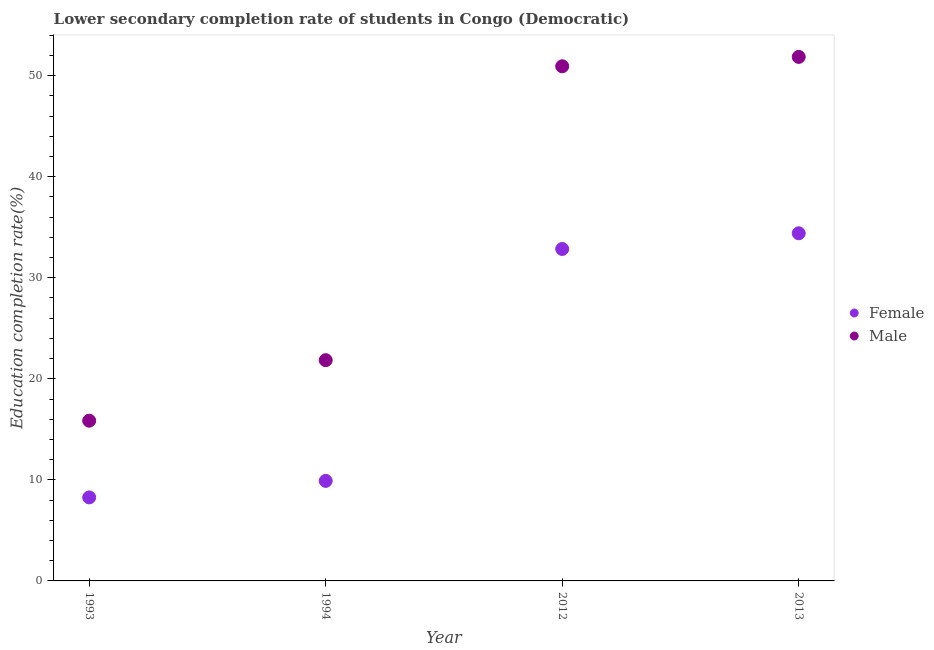Is the number of dotlines equal to the number of legend labels?
Your response must be concise. Yes. What is the education completion rate of female students in 1993?
Your answer should be very brief. 8.26. Across all years, what is the maximum education completion rate of male students?
Provide a succinct answer. 51.86. Across all years, what is the minimum education completion rate of male students?
Offer a terse response. 15.86. In which year was the education completion rate of female students maximum?
Your answer should be compact. 2013. In which year was the education completion rate of female students minimum?
Offer a very short reply. 1993. What is the total education completion rate of female students in the graph?
Make the answer very short. 85.41. What is the difference between the education completion rate of male students in 1994 and that in 2012?
Your response must be concise. -29.08. What is the difference between the education completion rate of male students in 1994 and the education completion rate of female students in 2012?
Offer a terse response. -11. What is the average education completion rate of female students per year?
Ensure brevity in your answer.  21.35. In the year 1993, what is the difference between the education completion rate of female students and education completion rate of male students?
Offer a very short reply. -7.59. In how many years, is the education completion rate of male students greater than 38 %?
Your response must be concise. 2. What is the ratio of the education completion rate of female students in 1994 to that in 2012?
Offer a very short reply. 0.3. Is the difference between the education completion rate of male students in 2012 and 2013 greater than the difference between the education completion rate of female students in 2012 and 2013?
Ensure brevity in your answer.  Yes. What is the difference between the highest and the second highest education completion rate of male students?
Keep it short and to the point. 0.93. What is the difference between the highest and the lowest education completion rate of female students?
Your answer should be compact. 26.14. In how many years, is the education completion rate of male students greater than the average education completion rate of male students taken over all years?
Your response must be concise. 2. How many dotlines are there?
Give a very brief answer. 2. Does the graph contain grids?
Keep it short and to the point. No. Where does the legend appear in the graph?
Offer a very short reply. Center right. How many legend labels are there?
Ensure brevity in your answer.  2. What is the title of the graph?
Your answer should be compact. Lower secondary completion rate of students in Congo (Democratic). Does "Private creditors" appear as one of the legend labels in the graph?
Provide a succinct answer. No. What is the label or title of the X-axis?
Ensure brevity in your answer.  Year. What is the label or title of the Y-axis?
Your response must be concise. Education completion rate(%). What is the Education completion rate(%) of Female in 1993?
Your answer should be very brief. 8.26. What is the Education completion rate(%) in Male in 1993?
Your answer should be compact. 15.86. What is the Education completion rate(%) of Female in 1994?
Offer a terse response. 9.9. What is the Education completion rate(%) of Male in 1994?
Offer a very short reply. 21.85. What is the Education completion rate(%) in Female in 2012?
Offer a very short reply. 32.85. What is the Education completion rate(%) in Male in 2012?
Give a very brief answer. 50.93. What is the Education completion rate(%) of Female in 2013?
Ensure brevity in your answer.  34.4. What is the Education completion rate(%) in Male in 2013?
Make the answer very short. 51.86. Across all years, what is the maximum Education completion rate(%) in Female?
Offer a terse response. 34.4. Across all years, what is the maximum Education completion rate(%) of Male?
Your response must be concise. 51.86. Across all years, what is the minimum Education completion rate(%) in Female?
Offer a very short reply. 8.26. Across all years, what is the minimum Education completion rate(%) in Male?
Give a very brief answer. 15.86. What is the total Education completion rate(%) of Female in the graph?
Offer a terse response. 85.41. What is the total Education completion rate(%) in Male in the graph?
Ensure brevity in your answer.  140.49. What is the difference between the Education completion rate(%) in Female in 1993 and that in 1994?
Ensure brevity in your answer.  -1.64. What is the difference between the Education completion rate(%) in Male in 1993 and that in 1994?
Ensure brevity in your answer.  -5.99. What is the difference between the Education completion rate(%) in Female in 1993 and that in 2012?
Your answer should be very brief. -24.59. What is the difference between the Education completion rate(%) of Male in 1993 and that in 2012?
Offer a very short reply. -35.07. What is the difference between the Education completion rate(%) of Female in 1993 and that in 2013?
Your response must be concise. -26.14. What is the difference between the Education completion rate(%) in Male in 1993 and that in 2013?
Keep it short and to the point. -36. What is the difference between the Education completion rate(%) of Female in 1994 and that in 2012?
Offer a terse response. -22.95. What is the difference between the Education completion rate(%) in Male in 1994 and that in 2012?
Your answer should be compact. -29.08. What is the difference between the Education completion rate(%) in Female in 1994 and that in 2013?
Ensure brevity in your answer.  -24.5. What is the difference between the Education completion rate(%) in Male in 1994 and that in 2013?
Provide a succinct answer. -30.01. What is the difference between the Education completion rate(%) of Female in 2012 and that in 2013?
Your response must be concise. -1.55. What is the difference between the Education completion rate(%) of Male in 2012 and that in 2013?
Make the answer very short. -0.93. What is the difference between the Education completion rate(%) in Female in 1993 and the Education completion rate(%) in Male in 1994?
Your answer should be compact. -13.58. What is the difference between the Education completion rate(%) of Female in 1993 and the Education completion rate(%) of Male in 2012?
Your response must be concise. -42.66. What is the difference between the Education completion rate(%) in Female in 1993 and the Education completion rate(%) in Male in 2013?
Your response must be concise. -43.59. What is the difference between the Education completion rate(%) of Female in 1994 and the Education completion rate(%) of Male in 2012?
Your answer should be compact. -41.03. What is the difference between the Education completion rate(%) of Female in 1994 and the Education completion rate(%) of Male in 2013?
Ensure brevity in your answer.  -41.96. What is the difference between the Education completion rate(%) of Female in 2012 and the Education completion rate(%) of Male in 2013?
Offer a terse response. -19.01. What is the average Education completion rate(%) in Female per year?
Your answer should be compact. 21.35. What is the average Education completion rate(%) of Male per year?
Make the answer very short. 35.12. In the year 1993, what is the difference between the Education completion rate(%) of Female and Education completion rate(%) of Male?
Provide a short and direct response. -7.59. In the year 1994, what is the difference between the Education completion rate(%) of Female and Education completion rate(%) of Male?
Make the answer very short. -11.95. In the year 2012, what is the difference between the Education completion rate(%) in Female and Education completion rate(%) in Male?
Provide a short and direct response. -18.08. In the year 2013, what is the difference between the Education completion rate(%) in Female and Education completion rate(%) in Male?
Your answer should be compact. -17.45. What is the ratio of the Education completion rate(%) in Female in 1993 to that in 1994?
Provide a succinct answer. 0.83. What is the ratio of the Education completion rate(%) in Male in 1993 to that in 1994?
Offer a very short reply. 0.73. What is the ratio of the Education completion rate(%) of Female in 1993 to that in 2012?
Give a very brief answer. 0.25. What is the ratio of the Education completion rate(%) in Male in 1993 to that in 2012?
Make the answer very short. 0.31. What is the ratio of the Education completion rate(%) in Female in 1993 to that in 2013?
Your answer should be compact. 0.24. What is the ratio of the Education completion rate(%) of Male in 1993 to that in 2013?
Ensure brevity in your answer.  0.31. What is the ratio of the Education completion rate(%) in Female in 1994 to that in 2012?
Provide a short and direct response. 0.3. What is the ratio of the Education completion rate(%) of Male in 1994 to that in 2012?
Provide a succinct answer. 0.43. What is the ratio of the Education completion rate(%) in Female in 1994 to that in 2013?
Provide a succinct answer. 0.29. What is the ratio of the Education completion rate(%) of Male in 1994 to that in 2013?
Offer a very short reply. 0.42. What is the ratio of the Education completion rate(%) in Female in 2012 to that in 2013?
Ensure brevity in your answer.  0.95. What is the ratio of the Education completion rate(%) of Male in 2012 to that in 2013?
Your response must be concise. 0.98. What is the difference between the highest and the second highest Education completion rate(%) of Female?
Ensure brevity in your answer.  1.55. What is the difference between the highest and the second highest Education completion rate(%) of Male?
Make the answer very short. 0.93. What is the difference between the highest and the lowest Education completion rate(%) in Female?
Make the answer very short. 26.14. What is the difference between the highest and the lowest Education completion rate(%) in Male?
Keep it short and to the point. 36. 